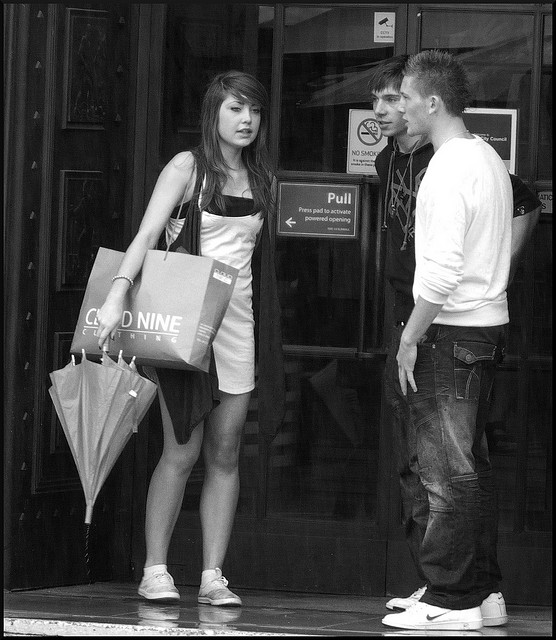Identify the text displayed in this image. Pull NINE 